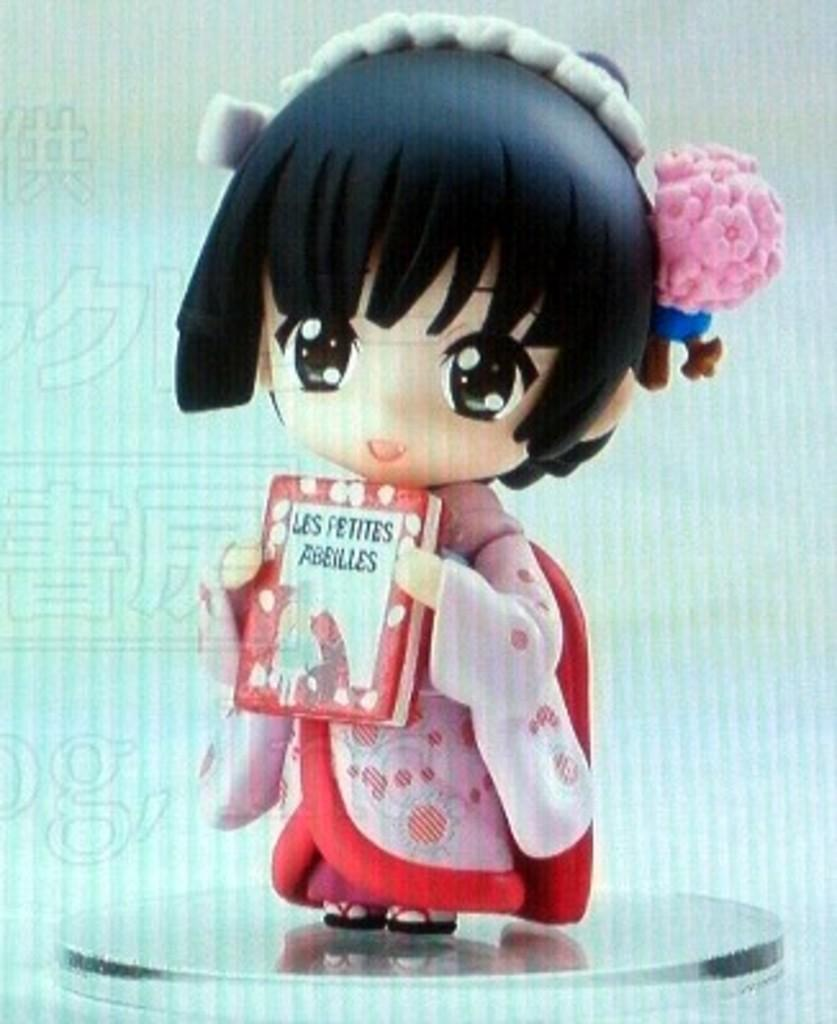What is the main subject of the image? There is a doll in the image. What is the doll holding? The doll is holding a box. On what surface is the doll placed? The doll is placed on a metal surface. Has the image been altered in any way? Yes, the image has been edited. What type of spy equipment can be seen in the image? There is no spy equipment present in the image; it features a doll holding a box on a metal surface. What type of salt is being used by the doll's father in the image? There is no father or salt present in the image; it only features a doll holding a box on a metal surface. 